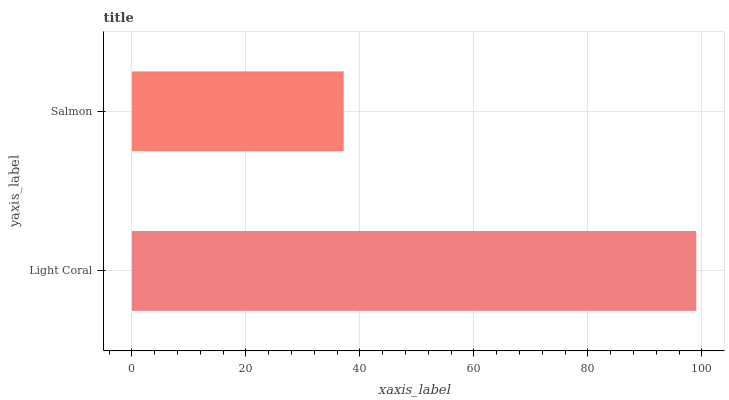Is Salmon the minimum?
Answer yes or no. Yes. Is Light Coral the maximum?
Answer yes or no. Yes. Is Salmon the maximum?
Answer yes or no. No. Is Light Coral greater than Salmon?
Answer yes or no. Yes. Is Salmon less than Light Coral?
Answer yes or no. Yes. Is Salmon greater than Light Coral?
Answer yes or no. No. Is Light Coral less than Salmon?
Answer yes or no. No. Is Light Coral the high median?
Answer yes or no. Yes. Is Salmon the low median?
Answer yes or no. Yes. Is Salmon the high median?
Answer yes or no. No. Is Light Coral the low median?
Answer yes or no. No. 